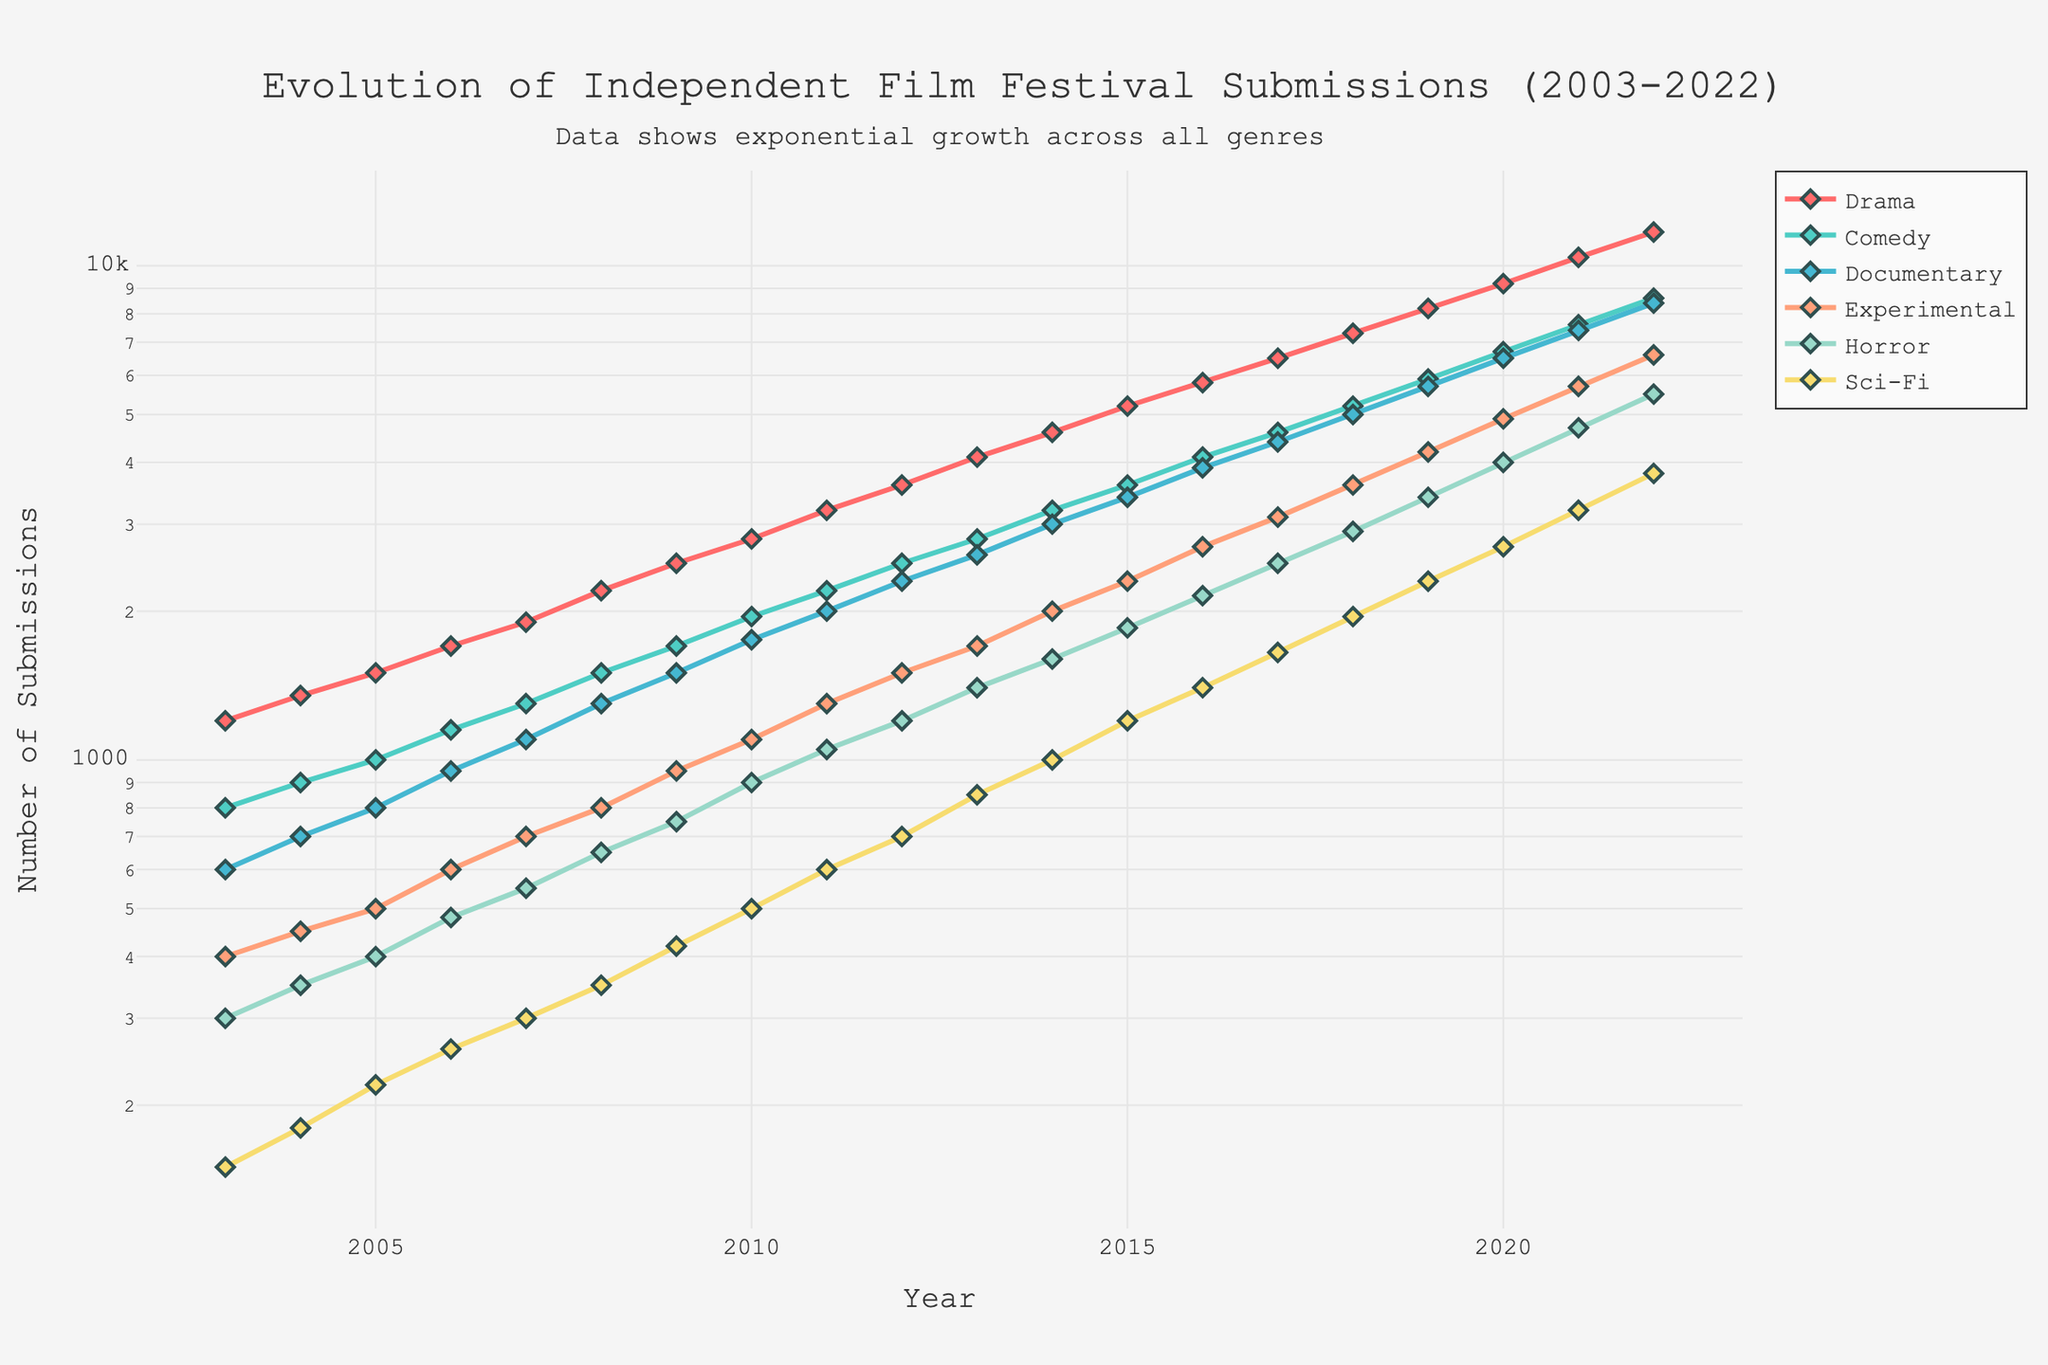What's the trend for Drama submissions from 2003 to 2022? Look at the orange line representing Drama. It shows a consistent upward trend, from 1200 in 2003 to 11700 in 2022.
Answer: Consistent upward trend Which genre had the highest number of submissions in 2022? Compare the values for each genre in 2022. Drama has the highest value of 11700.
Answer: Drama By how much did Comedy submissions increase from 2003 to 2022? Subtract the number of Comedy submissions in 2003 from the number in 2022: 8600 - 800 = 7800.
Answer: 7800 What is the average number of Documentary submissions from 2010 to 2022? Sum the number of Documentary submissions from 2010 to 2022 and divide by the number of years (13): (1750 + 2000 + 2300 + 2600 + 3000 + 3400 + 3900 + 4400 + 5000 + 5700 + 6500 + 7400 + 8400) / 13 = 4177.
Answer: 4177 Compare the growth trends of Experimental and Horror genres between 2003 and 2022. Visual comparison of the pink line (Experimental) and the red line (Horror) shows that both genres grew, but Horror had a more substantial increase. Experimental went from 400 to 6600, while Horror went from 300 to 5500.
Answer: Horror had a more substantial increase During which years did Sci-Fi see the highest growth in submissions? Look at the light purple line for the steepest slopes. The years 2021 and 2022 show significant growth, jumping from 3200 to 3800.
Answer: 2021-2022 What's the total number of submissions in all genres for the year 2019? Add the number of submissions for each genre in 2019: 8200 + 5900 + 5700 + 4200 + 3400 + 2300 = 29700.
Answer: 29700 Which genre had the least number of submissions in 2008 and by how much did it lag the next least submitted genre? Focus on 2008 values. Sci-Fi had 350, while Horror had 650. The difference is 650 - 350 = 300.
Answer: Sci-Fi, 300 How did the number of Documentary submissions in 2015 compare to the number of Horror submissions in 2016? The number of Documentary submissions in 2015 was 3400 and Horror in 2016 was 2150. Documentary had 1250 more submissions.
Answer: Documentary had 1250 more What is noticeable about the number of Experimental submissions over the years? The Experimental genre (visualized in pink) shows a steady and continuous increase over the two decades, starting at 400 and reaching 6600 by 2022.
Answer: Steady continuous increase 